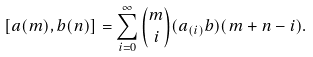Convert formula to latex. <formula><loc_0><loc_0><loc_500><loc_500>[ a ( m ) , b ( n ) ] = \sum _ { i = 0 } ^ { \infty } \binom { m } { i } ( a _ { ( i ) } b ) ( m + n - i ) .</formula> 